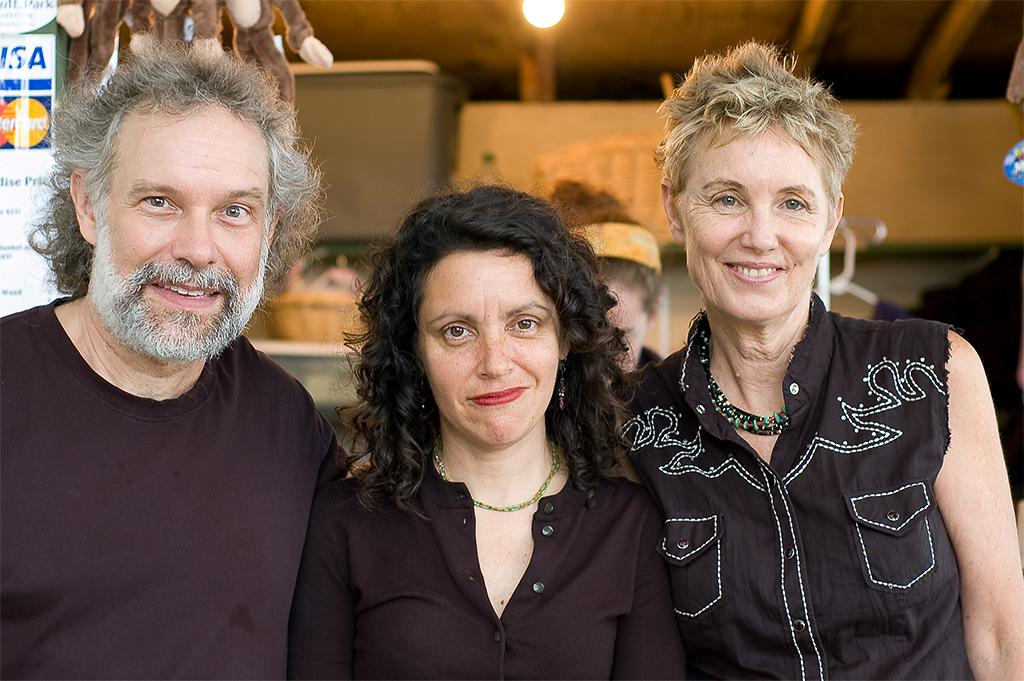How many people are in the image? There are three persons in the image. What are the people wearing? All three persons are wearing black dress. Are there any accessories visible on the ladies? Yes, two ladies are wearing chains. What can be seen in the background on the left side? There is a board in the background on the left side. What is attached to the board? There are objects hanging on the board. Can you describe the lighting in the image? Yes, there is a light in the image. What year is the judge presiding over in the image? There is no judge or any indication of a specific year in the image. 